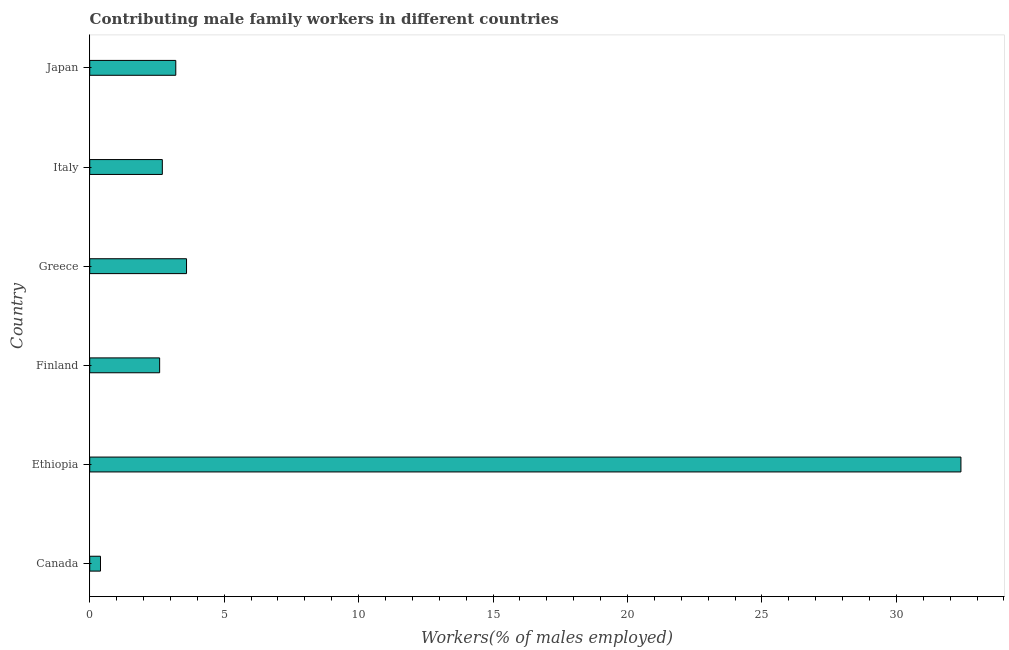What is the title of the graph?
Make the answer very short. Contributing male family workers in different countries. What is the label or title of the X-axis?
Provide a succinct answer. Workers(% of males employed). What is the contributing male family workers in Ethiopia?
Provide a succinct answer. 32.4. Across all countries, what is the maximum contributing male family workers?
Your response must be concise. 32.4. Across all countries, what is the minimum contributing male family workers?
Your answer should be compact. 0.4. In which country was the contributing male family workers maximum?
Provide a succinct answer. Ethiopia. What is the sum of the contributing male family workers?
Your answer should be compact. 44.9. What is the average contributing male family workers per country?
Offer a very short reply. 7.48. What is the median contributing male family workers?
Offer a terse response. 2.95. What is the difference between the highest and the second highest contributing male family workers?
Offer a very short reply. 28.8. Is the sum of the contributing male family workers in Canada and Greece greater than the maximum contributing male family workers across all countries?
Your response must be concise. No. What is the difference between the highest and the lowest contributing male family workers?
Ensure brevity in your answer.  32. In how many countries, is the contributing male family workers greater than the average contributing male family workers taken over all countries?
Your answer should be very brief. 1. How many bars are there?
Your response must be concise. 6. Are all the bars in the graph horizontal?
Offer a terse response. Yes. How many countries are there in the graph?
Provide a short and direct response. 6. Are the values on the major ticks of X-axis written in scientific E-notation?
Your answer should be compact. No. What is the Workers(% of males employed) of Canada?
Your answer should be compact. 0.4. What is the Workers(% of males employed) of Ethiopia?
Keep it short and to the point. 32.4. What is the Workers(% of males employed) of Finland?
Provide a short and direct response. 2.6. What is the Workers(% of males employed) in Greece?
Provide a succinct answer. 3.6. What is the Workers(% of males employed) of Italy?
Keep it short and to the point. 2.7. What is the Workers(% of males employed) of Japan?
Your answer should be very brief. 3.2. What is the difference between the Workers(% of males employed) in Canada and Ethiopia?
Your response must be concise. -32. What is the difference between the Workers(% of males employed) in Canada and Finland?
Make the answer very short. -2.2. What is the difference between the Workers(% of males employed) in Ethiopia and Finland?
Ensure brevity in your answer.  29.8. What is the difference between the Workers(% of males employed) in Ethiopia and Greece?
Offer a terse response. 28.8. What is the difference between the Workers(% of males employed) in Ethiopia and Italy?
Keep it short and to the point. 29.7. What is the difference between the Workers(% of males employed) in Ethiopia and Japan?
Provide a succinct answer. 29.2. What is the difference between the Workers(% of males employed) in Finland and Japan?
Provide a short and direct response. -0.6. What is the difference between the Workers(% of males employed) in Greece and Italy?
Your answer should be very brief. 0.9. What is the ratio of the Workers(% of males employed) in Canada to that in Ethiopia?
Provide a succinct answer. 0.01. What is the ratio of the Workers(% of males employed) in Canada to that in Finland?
Your answer should be compact. 0.15. What is the ratio of the Workers(% of males employed) in Canada to that in Greece?
Your response must be concise. 0.11. What is the ratio of the Workers(% of males employed) in Canada to that in Italy?
Offer a terse response. 0.15. What is the ratio of the Workers(% of males employed) in Ethiopia to that in Finland?
Offer a very short reply. 12.46. What is the ratio of the Workers(% of males employed) in Ethiopia to that in Greece?
Provide a succinct answer. 9. What is the ratio of the Workers(% of males employed) in Ethiopia to that in Italy?
Your response must be concise. 12. What is the ratio of the Workers(% of males employed) in Ethiopia to that in Japan?
Make the answer very short. 10.12. What is the ratio of the Workers(% of males employed) in Finland to that in Greece?
Offer a terse response. 0.72. What is the ratio of the Workers(% of males employed) in Finland to that in Japan?
Your answer should be very brief. 0.81. What is the ratio of the Workers(% of males employed) in Greece to that in Italy?
Ensure brevity in your answer.  1.33. What is the ratio of the Workers(% of males employed) in Greece to that in Japan?
Your answer should be compact. 1.12. What is the ratio of the Workers(% of males employed) in Italy to that in Japan?
Your answer should be very brief. 0.84. 